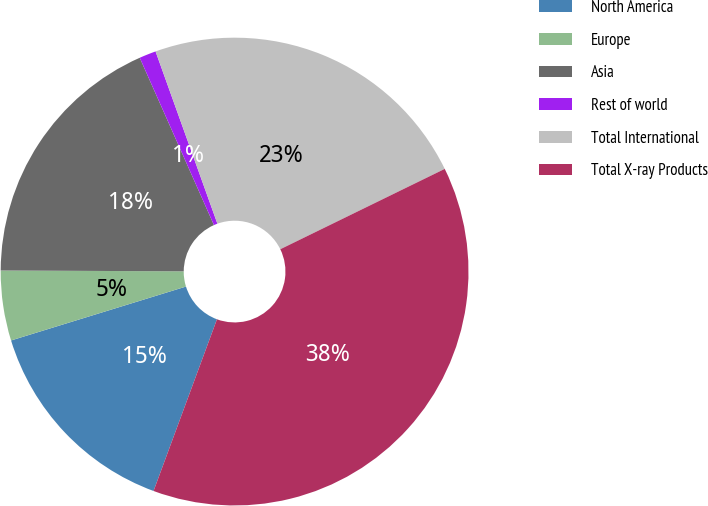Convert chart to OTSL. <chart><loc_0><loc_0><loc_500><loc_500><pie_chart><fcel>North America<fcel>Europe<fcel>Asia<fcel>Rest of world<fcel>Total International<fcel>Total X-ray Products<nl><fcel>14.61%<fcel>4.83%<fcel>18.28%<fcel>1.16%<fcel>23.25%<fcel>37.86%<nl></chart> 